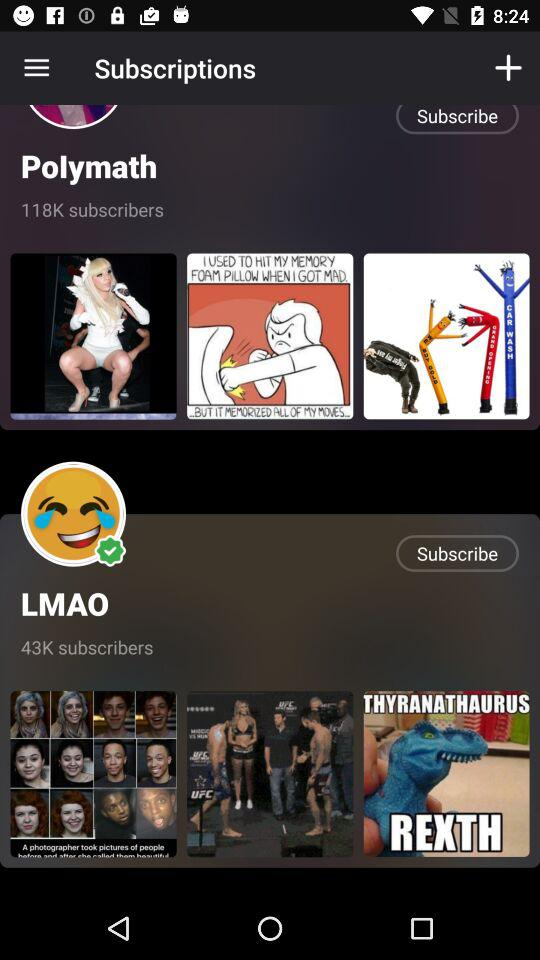How many people subscribe to the LMAO? There are 43, 000 people who subscribe to the LMAO. 